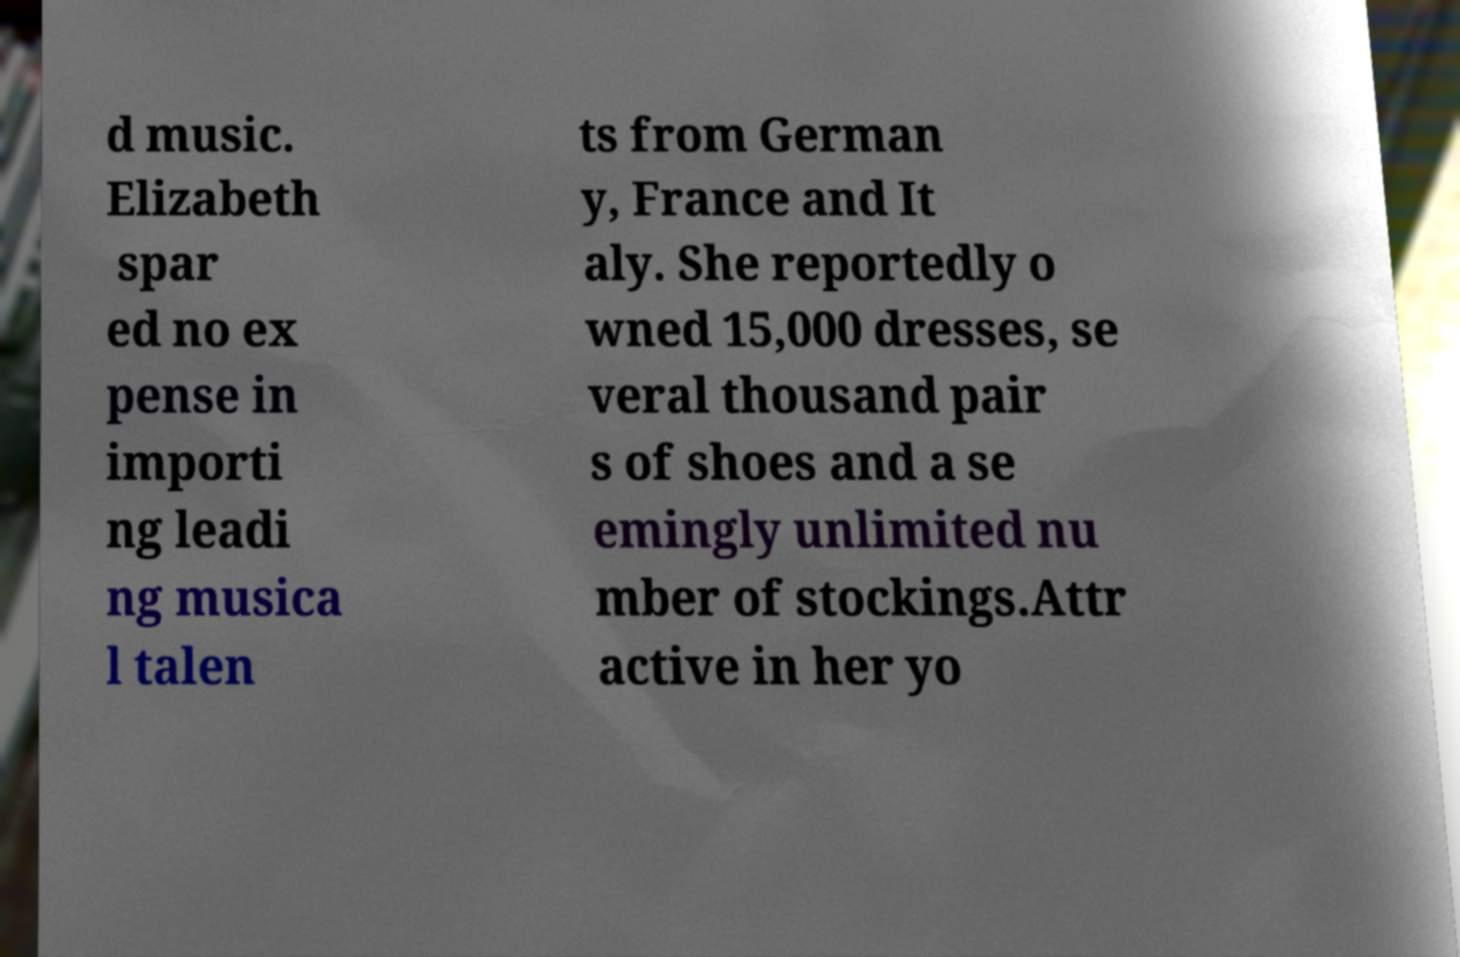What messages or text are displayed in this image? I need them in a readable, typed format. d music. Elizabeth spar ed no ex pense in importi ng leadi ng musica l talen ts from German y, France and It aly. She reportedly o wned 15,000 dresses, se veral thousand pair s of shoes and a se emingly unlimited nu mber of stockings.Attr active in her yo 